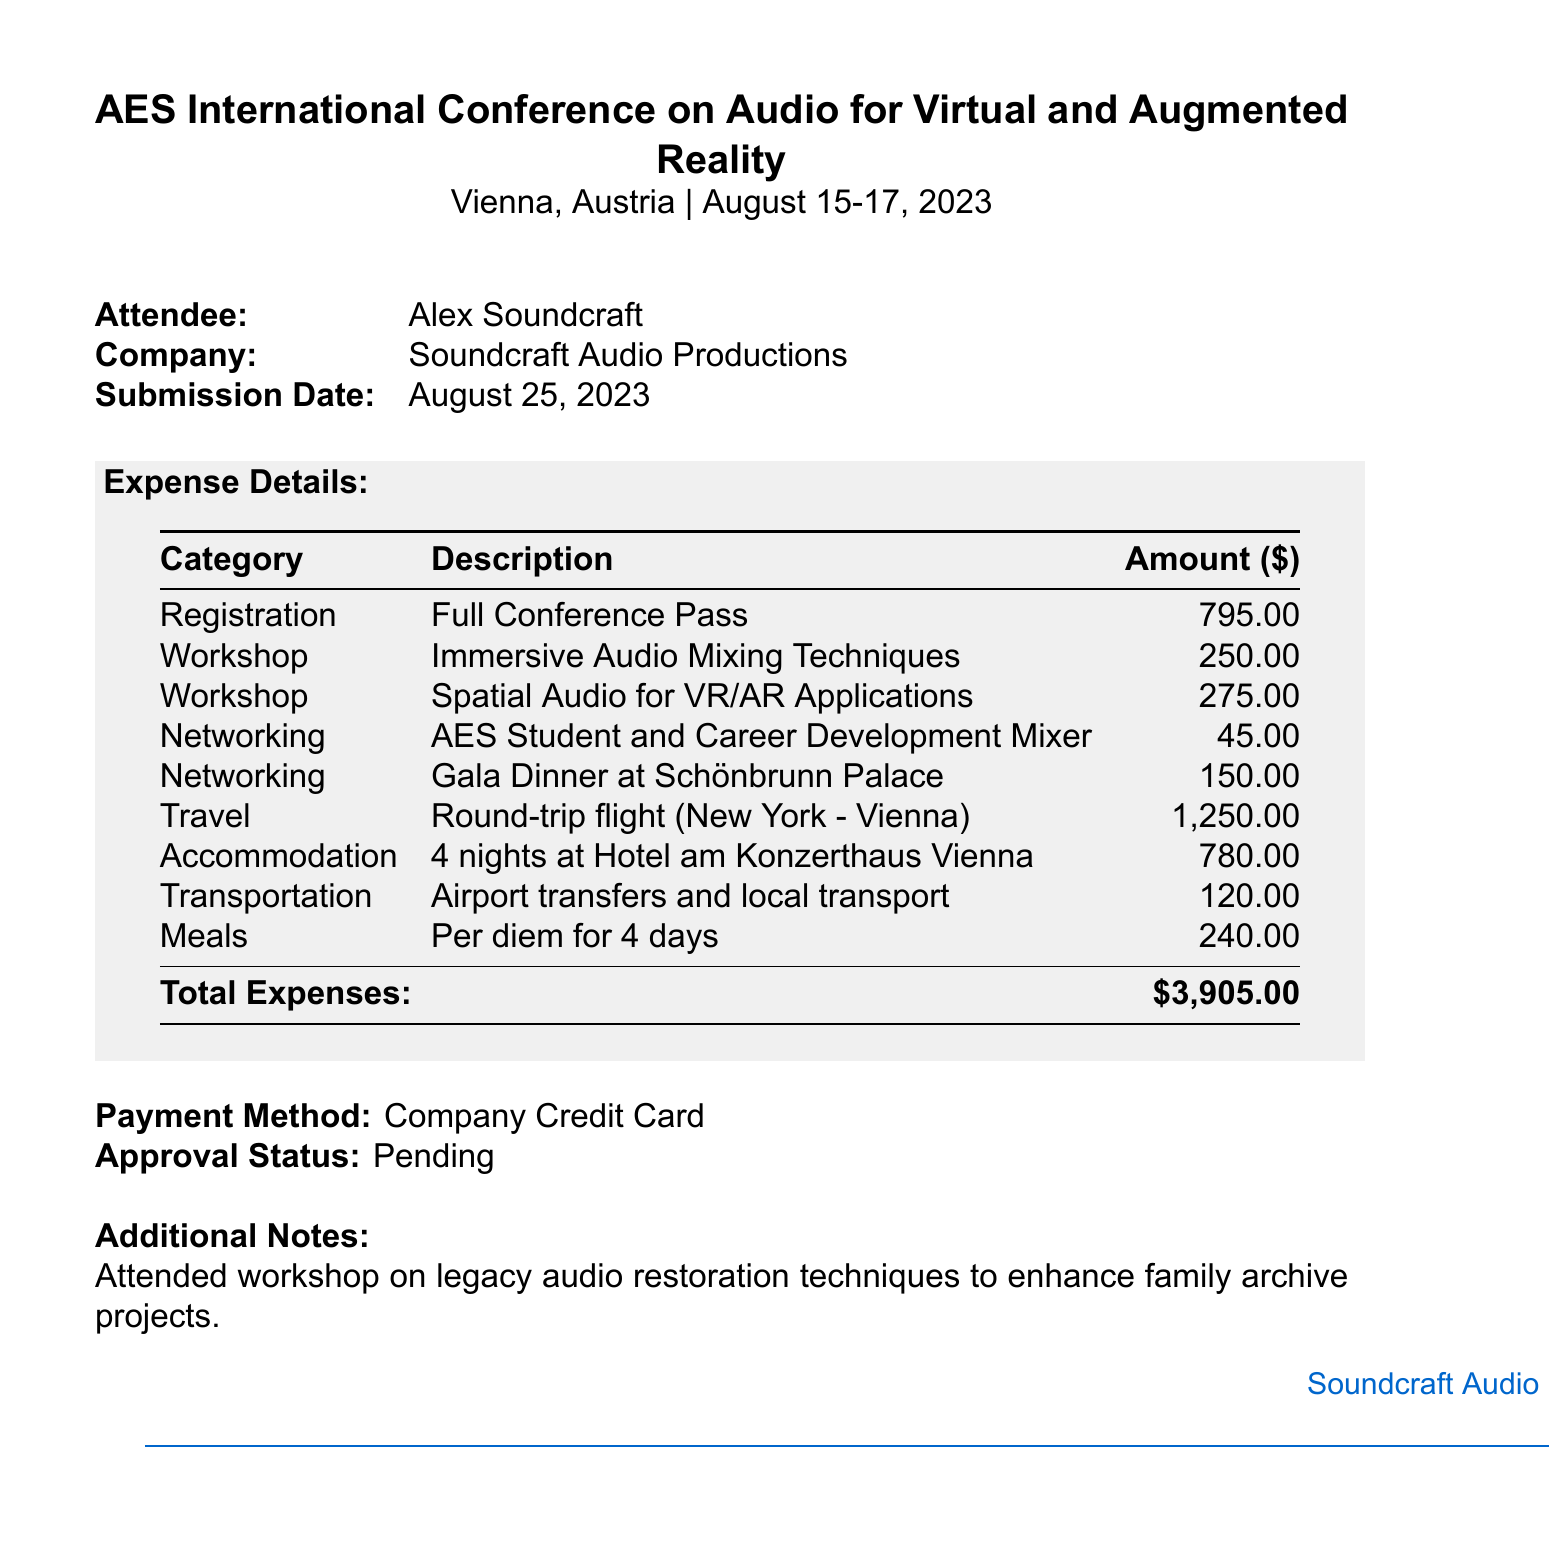What is the attendee's name? The attendee's name is provided at the top of the document.
Answer: Alex Soundcraft What is the location of the conference? The document specifies the conference's location.
Answer: Vienna, Austria What is the total amount of expenses? The total expenses are clearly outlined at the bottom of the expense details.
Answer: $3,905.00 How many workshops did the attendee participate in? The document lists the number of workshops under the expense details.
Answer: 2 What was the payment method used? The document specifically mentions the payment method used for the expenses.
Answer: Company Credit Card What was the submission date of the expense report? The submission date is stated in the details section of the document.
Answer: August 25, 2023 What type of event was the AES Student and Career Development Mixer? The event is categorized under networking in the document.
Answer: Networking What is the expense amount for the Gala Dinner? The document lists the amount associated with the Gala Dinner.
Answer: $150.00 What is noted in the additional notes section? The additional notes section provides insights into workshops attended.
Answer: Attended workshop on legacy audio restoration techniques to enhance family archive projects 